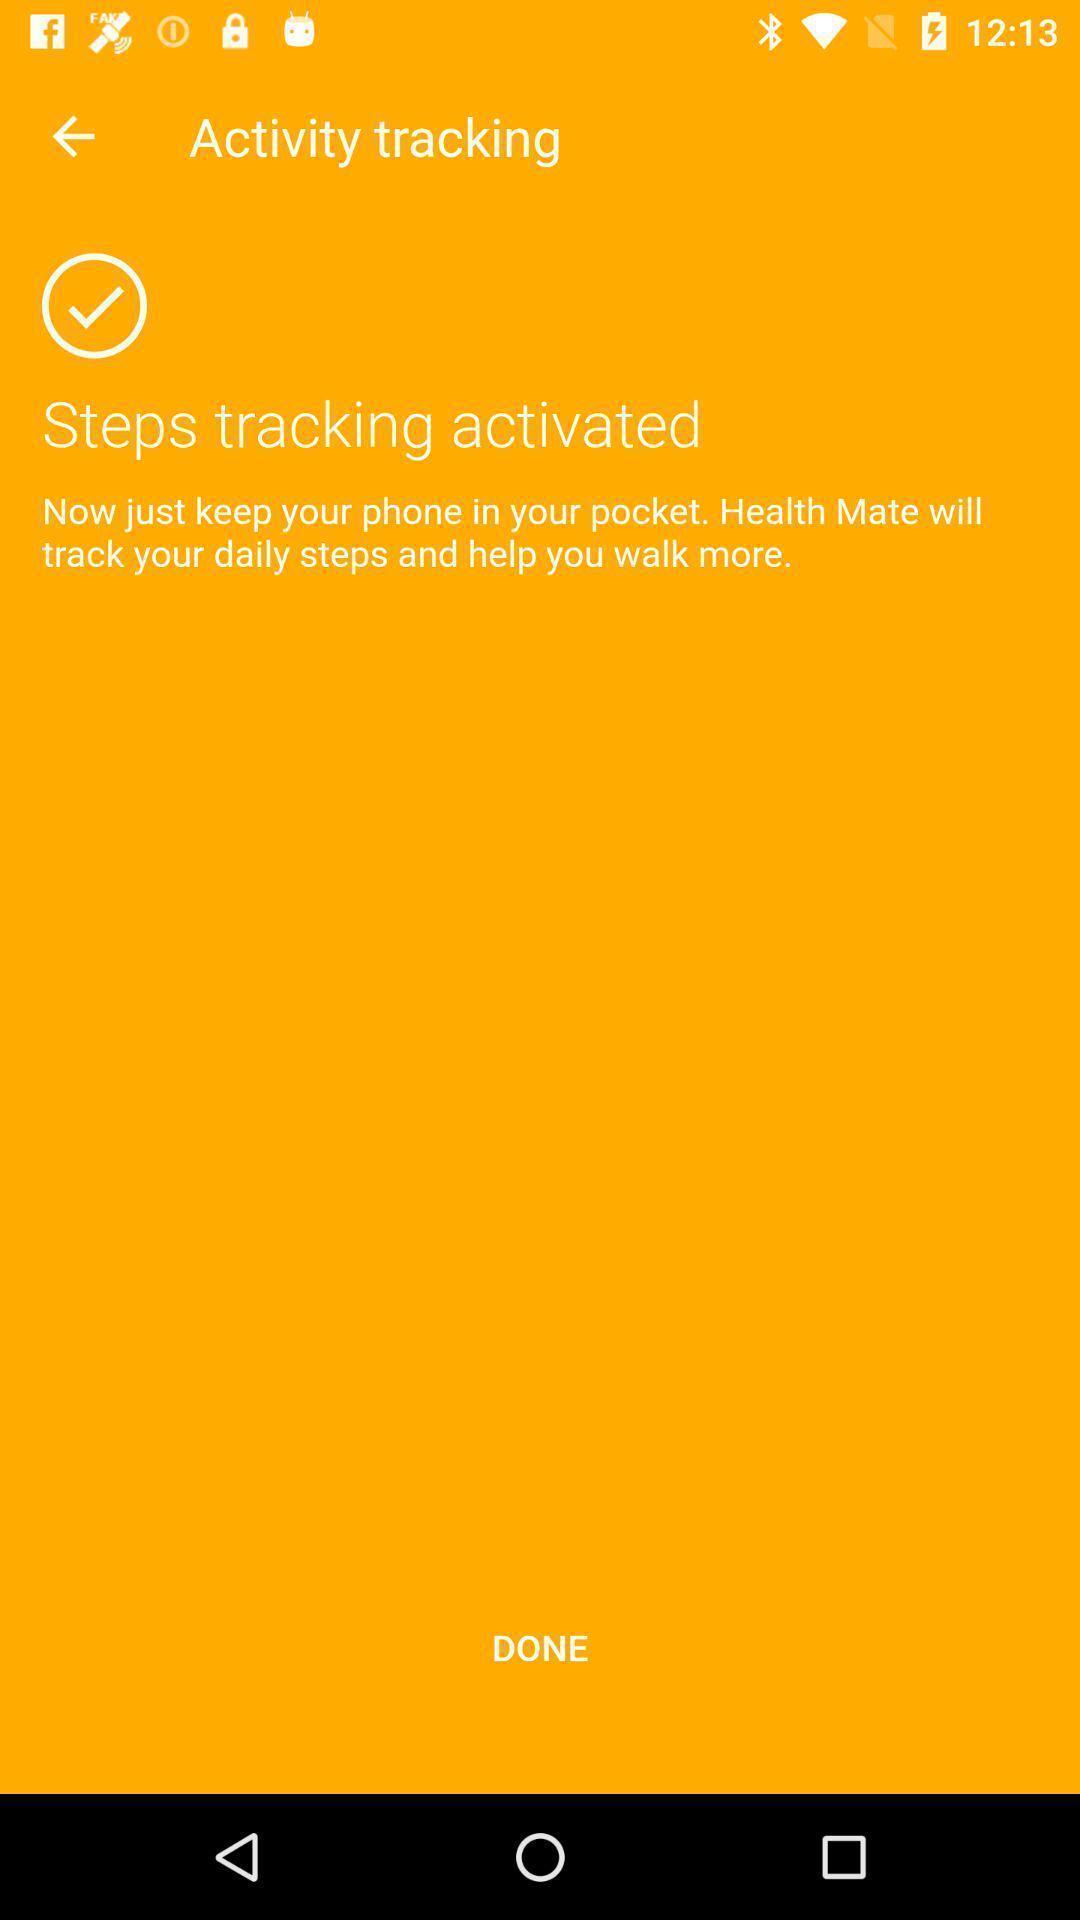Explain what's happening in this screen capture. Tracking page of a step tracking app. 